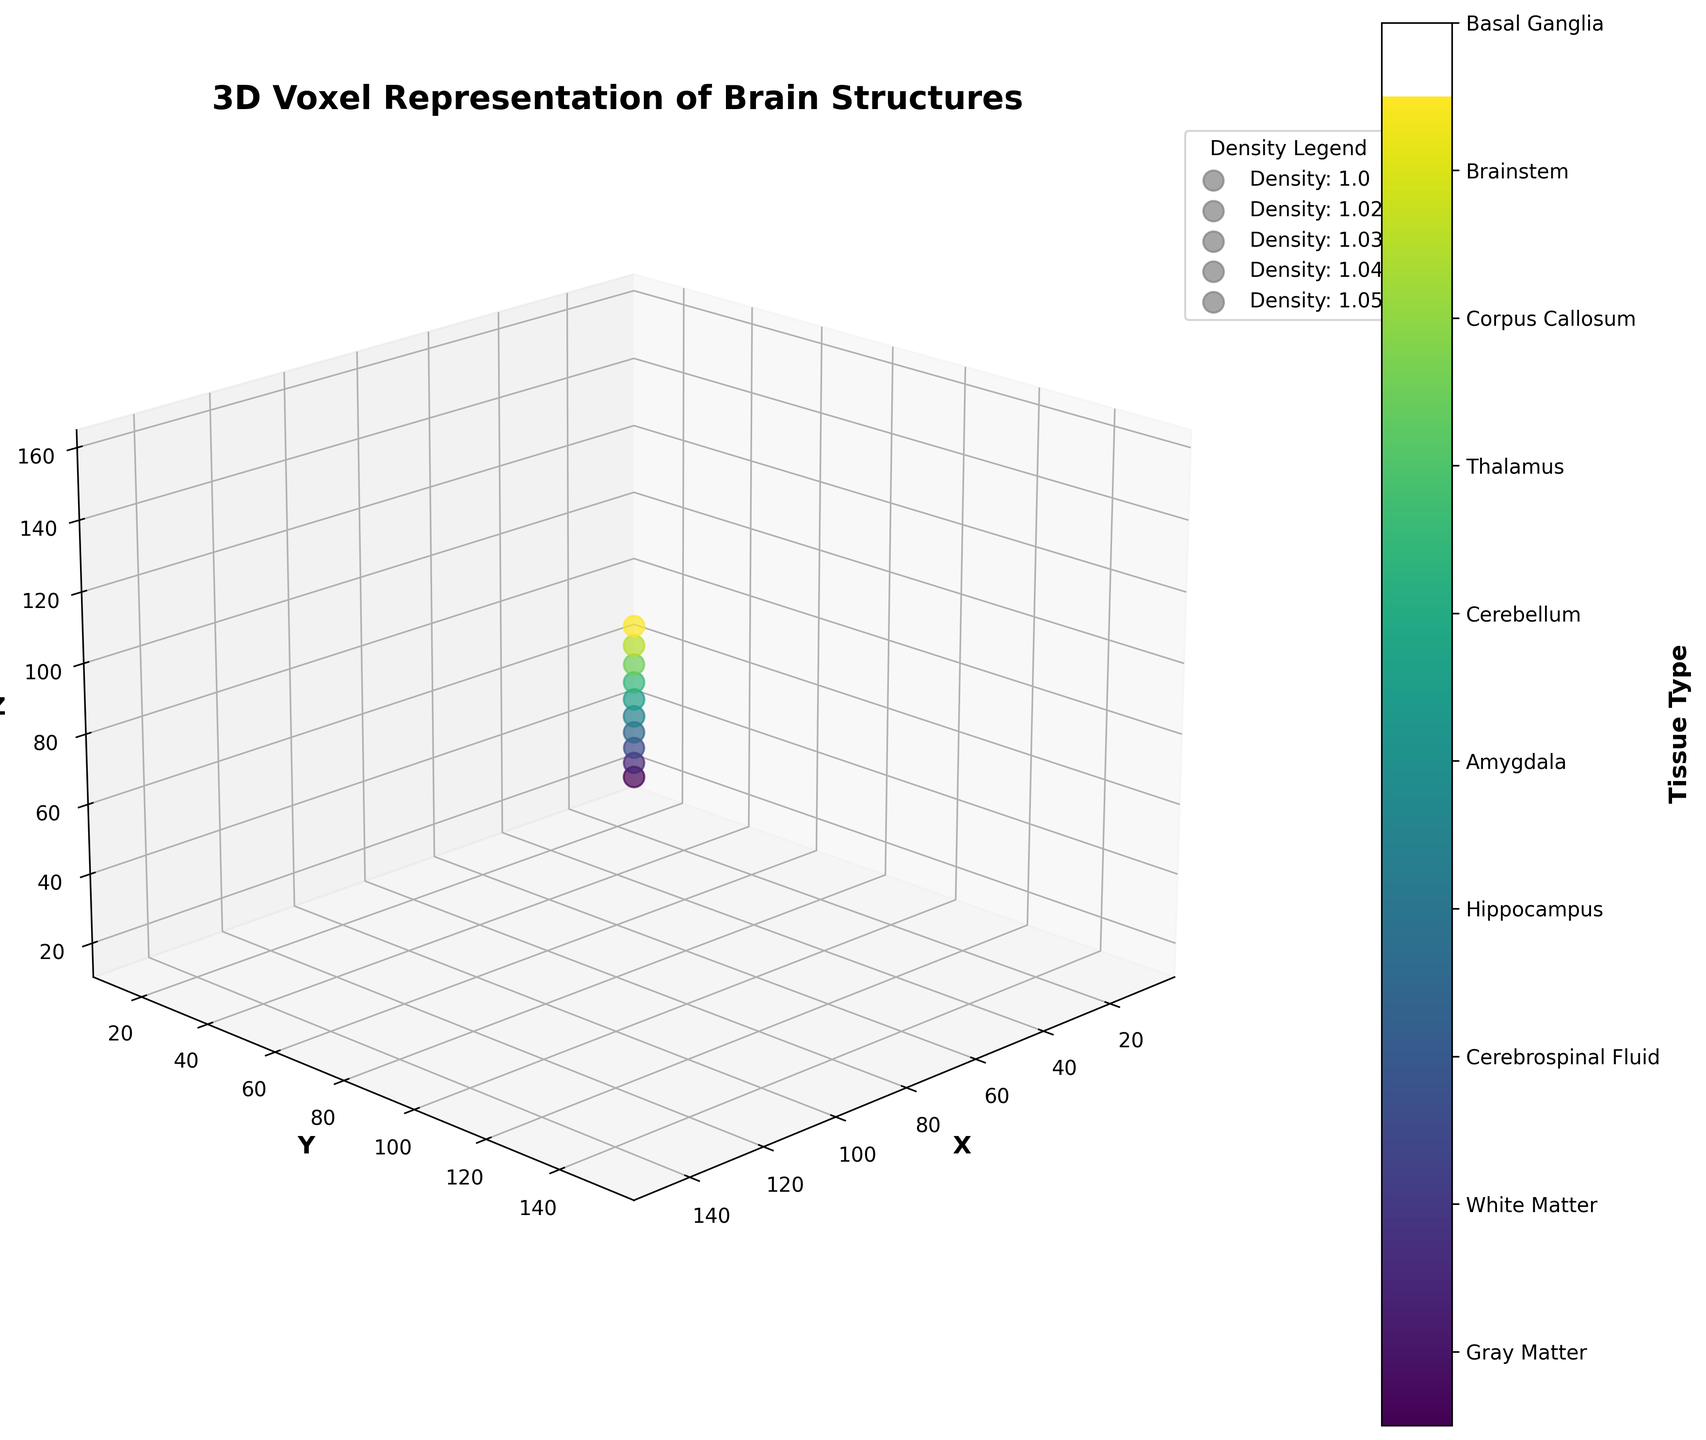What is the title of the figure? The title of a figure is usually displayed at the top in a larger or bold font. In this figure, the title is displayed clearly at the top and reads "3D Voxel Representation of Brain Structures".
Answer: 3D Voxel Representation of Brain Structures What does the figure's color bar represent? The color bar is used to indicate different tissue types in the brain. Since each tissue type is assigned a different color, the color bar helps to identify these types. It is specified on the color bar label as 'Tissue Type'.
Answer: Tissue types How are the voxels colored in the figure? The voxels are colored based on the tissue types they represent. Each tissue type is given a specific color, as indicated by the color bar on the side of the plot.
Answer: Based on tissue types Which tissue type has the highest density in the figure? By examining the sizes of the voxels and the density legend, we find that the Amygdala and Brainstem are represented by the largest voxels, whose density is 1.05.
Answer: Amygdala and Brainstem What is the label of the X-axis in the figure? Axis labels are found next to the respective axis. In this figure, the label for the X-axis is 'X', indicating the horizontal spatial dimension.
Answer: X How many different tissue types are displayed in the figure? By referring to the color bar and the legend, we can count the number of unique tissue types. The figure depicts 10 different tissue types: Gray Matter, White Matter, Cerebrospinal Fluid, Hippocampus, Amygdala, Cerebellum, Thalamus, Corpus Callosum, Brainstem, and Basal Ganglia.
Answer: 10 Which tissue type has the voxel closest to the origin (0,0,0)? The origin in a 3D figure is the point (0,0,0). By examining the coordinates of the voxels, the voxel with the coordinates closest to the origin is Gray Matter at (10, 15, 20).
Answer: Gray Matter Which tissue types have voxels with equal densities? We need to find the tissue types with the same numerical value for density, by looking at the density values. Both Gray Matter and Basal Ganglia have a density of 1.04.
Answer: Gray Matter and Basal Ganglia Which tissue type is located at coordinates (85, 90, 95)? The coordinates for each voxel can be matched with the tissue type in the figure description. The voxel at (85, 90, 95) corresponds to the Cerebellum.
Answer: Cerebellum How does voxel size relate to density in the figure? Size of the voxels is scaled proportionally to their density. Larger voxels represent higher density tissues, as indicated by the figure's legend.
Answer: Larger voxels represent higher density tissues 